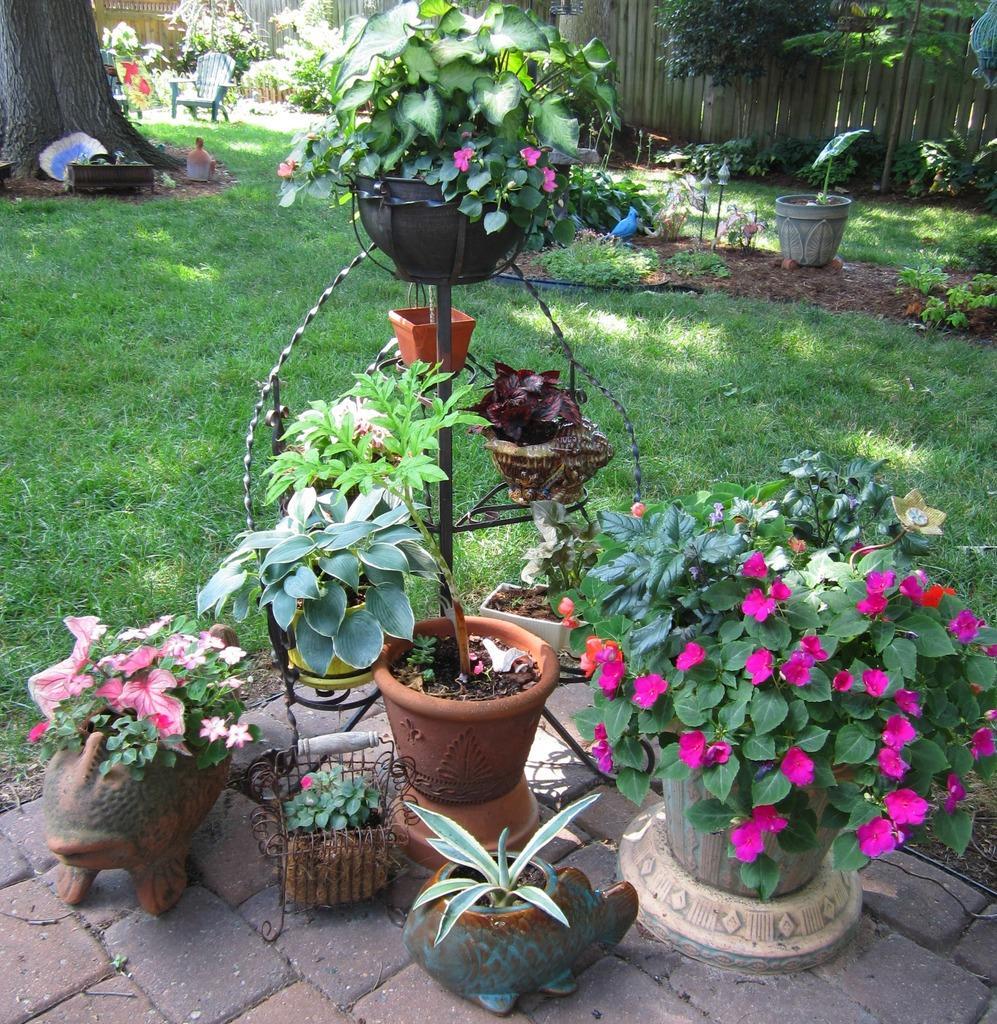Can you describe this image briefly? In this picture I can see grass. I can see plants, flowers, tree trunk and some other objects, and in the background there is fence. 